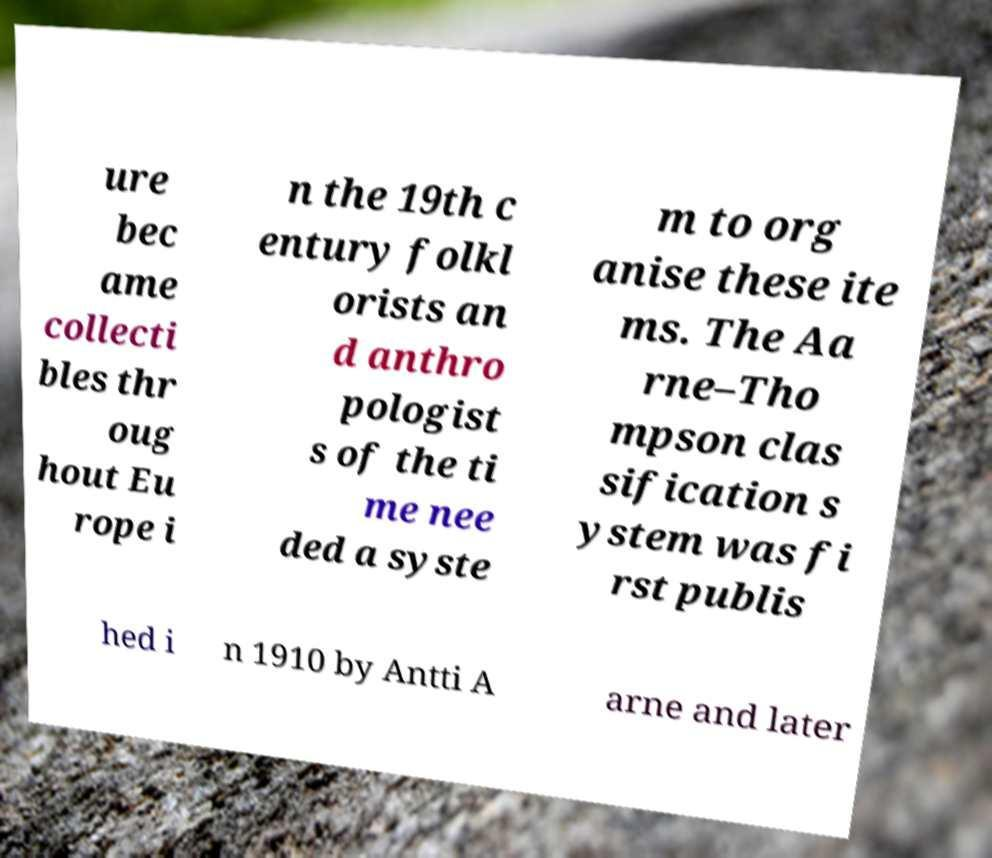Could you extract and type out the text from this image? ure bec ame collecti bles thr oug hout Eu rope i n the 19th c entury folkl orists an d anthro pologist s of the ti me nee ded a syste m to org anise these ite ms. The Aa rne–Tho mpson clas sification s ystem was fi rst publis hed i n 1910 by Antti A arne and later 